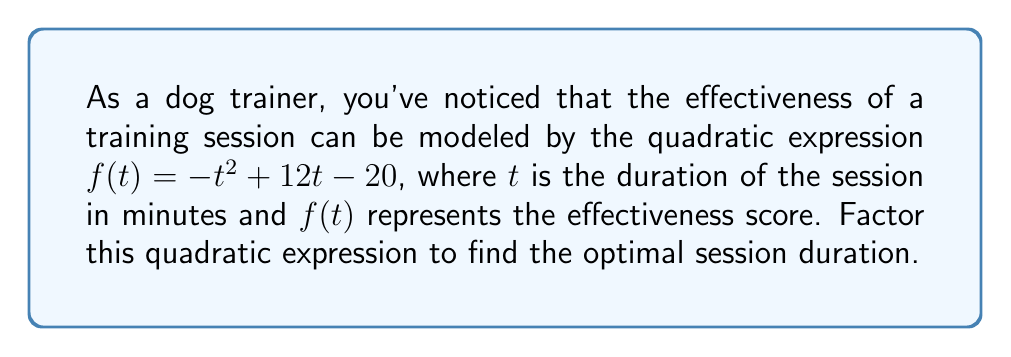Solve this math problem. To factor this quadratic expression, we'll follow these steps:

1) First, identify the coefficients:
   $a = -1$, $b = 12$, and $c = -20$

2) We need to find two numbers that multiply to give $ac$ and add to give $b$:
   $ac = (-1)(-20) = 20$
   We need two numbers that multiply to 20 and add to 12.
   These numbers are 10 and 2.

3) Rewrite the middle term using these numbers:
   $-t^2 + 10t + 2t - 20$

4) Group the terms:
   $(-t^2 + 10t) + (2t - 20)$

5) Factor out the common factor from each group:
   $-t(t - 10) + 2(t - 10)$

6) Factor out the common binomial:
   $(t - 10)(-t + 2)$

7) The factored expression is:
   $-(t - 10)(t - 2)$

The roots of this quadratic are at $t = 10$ and $t = 2$. Since the leading coefficient is negative, the parabola opens downward, and the vertex (which represents the maximum point) is halfway between these roots.

The optimal duration is therefore:
$\frac{10 + 2}{2} = 6$ minutes
Answer: $f(t) = -(t - 10)(t - 2)$
Optimal duration: 6 minutes 